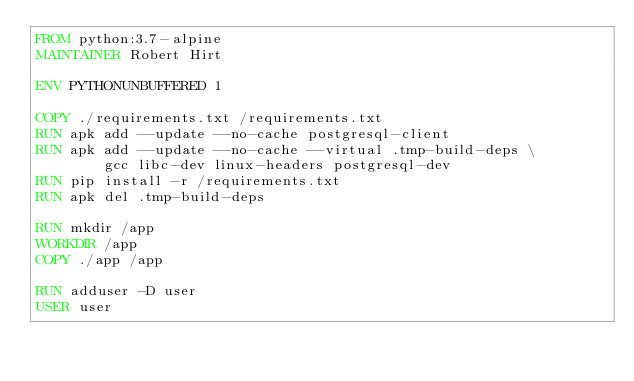Convert code to text. <code><loc_0><loc_0><loc_500><loc_500><_Dockerfile_>FROM python:3.7-alpine
MAINTAINER Robert Hirt

ENV PYTHONUNBUFFERED 1

COPY ./requirements.txt /requirements.txt
RUN apk add --update --no-cache postgresql-client
RUN apk add --update --no-cache --virtual .tmp-build-deps \
        gcc libc-dev linux-headers postgresql-dev
RUN pip install -r /requirements.txt
RUN apk del .tmp-build-deps

RUN mkdir /app
WORKDIR /app
COPY ./app /app

RUN adduser -D user
USER user
</code> 